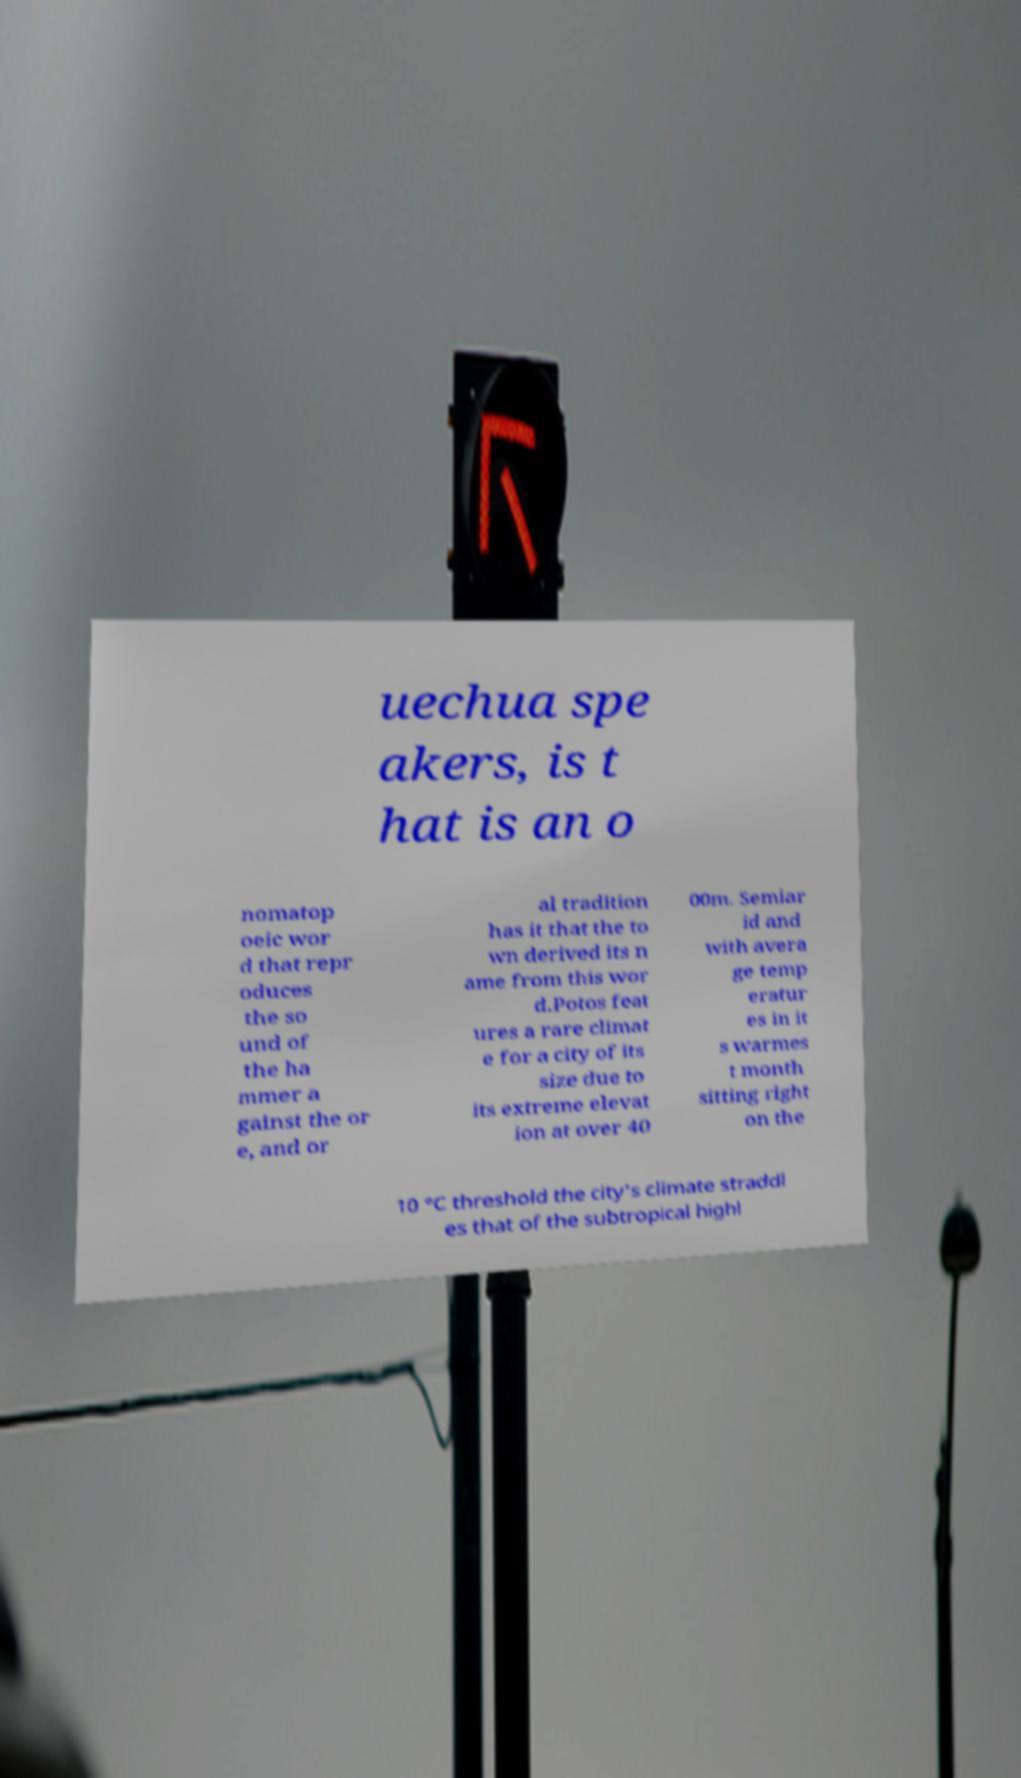Could you assist in decoding the text presented in this image and type it out clearly? uechua spe akers, is t hat is an o nomatop oeic wor d that repr oduces the so und of the ha mmer a gainst the or e, and or al tradition has it that the to wn derived its n ame from this wor d.Potos feat ures a rare climat e for a city of its size due to its extreme elevat ion at over 40 00m. Semiar id and with avera ge temp eratur es in it s warmes t month sitting right on the 10 °C threshold the city's climate straddl es that of the subtropical highl 